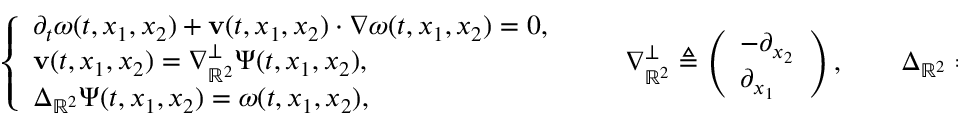Convert formula to latex. <formula><loc_0><loc_0><loc_500><loc_500>\left \{ \begin{array} { l l } { \partial _ { t } \omega ( t , x _ { 1 } , x _ { 2 } ) + v ( t , x _ { 1 } , x _ { 2 } ) \cdot \nabla \omega ( t , x _ { 1 } , x _ { 2 } ) = 0 , } \\ { v ( t , x _ { 1 } , x _ { 2 } ) = \nabla _ { \mathbb { R } ^ { 2 } } ^ { \perp } \Psi ( t , x _ { 1 } , x _ { 2 } ) , } \\ { \Delta _ { \mathbb { R } ^ { 2 } } \Psi ( t , x _ { 1 } , x _ { 2 } ) = \omega ( t , x _ { 1 } , x _ { 2 } ) , } \end{array} \quad \nabla _ { \mathbb { R } ^ { 2 } } ^ { \perp } \triangle q \left ( \begin{array} { l } { - \partial _ { x _ { 2 } } } \\ { \partial _ { x _ { 1 } } } \end{array} \right ) , \quad \Delta _ { \mathbb { R } ^ { 2 } } \triangle q \partial _ { x _ { 1 } } ^ { 2 } + \partial _ { x _ { 2 } } ^ { 2 } .</formula> 